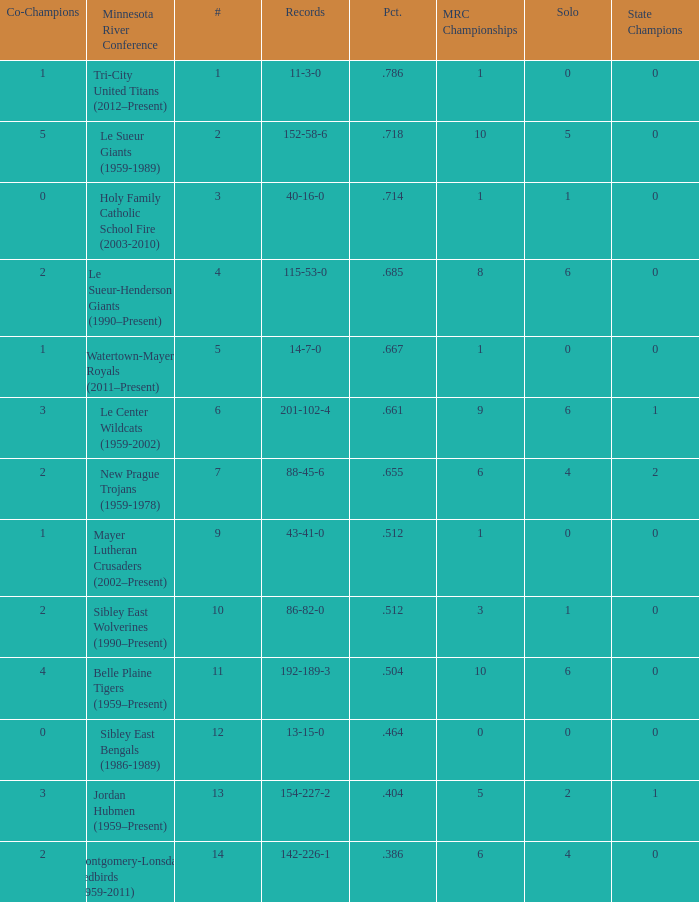How many teams are #2 on the list? 1.0. 